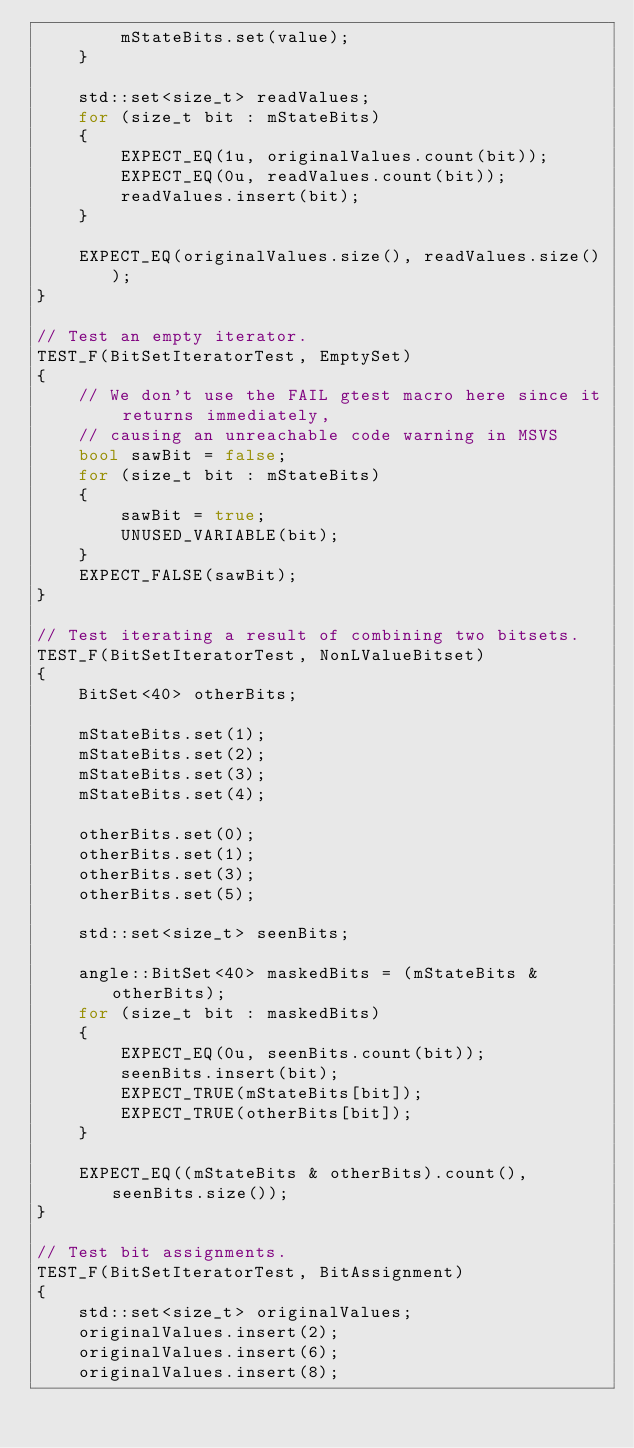Convert code to text. <code><loc_0><loc_0><loc_500><loc_500><_C++_>        mStateBits.set(value);
    }

    std::set<size_t> readValues;
    for (size_t bit : mStateBits)
    {
        EXPECT_EQ(1u, originalValues.count(bit));
        EXPECT_EQ(0u, readValues.count(bit));
        readValues.insert(bit);
    }

    EXPECT_EQ(originalValues.size(), readValues.size());
}

// Test an empty iterator.
TEST_F(BitSetIteratorTest, EmptySet)
{
    // We don't use the FAIL gtest macro here since it returns immediately,
    // causing an unreachable code warning in MSVS
    bool sawBit = false;
    for (size_t bit : mStateBits)
    {
        sawBit = true;
        UNUSED_VARIABLE(bit);
    }
    EXPECT_FALSE(sawBit);
}

// Test iterating a result of combining two bitsets.
TEST_F(BitSetIteratorTest, NonLValueBitset)
{
    BitSet<40> otherBits;

    mStateBits.set(1);
    mStateBits.set(2);
    mStateBits.set(3);
    mStateBits.set(4);

    otherBits.set(0);
    otherBits.set(1);
    otherBits.set(3);
    otherBits.set(5);

    std::set<size_t> seenBits;

    angle::BitSet<40> maskedBits = (mStateBits & otherBits);
    for (size_t bit : maskedBits)
    {
        EXPECT_EQ(0u, seenBits.count(bit));
        seenBits.insert(bit);
        EXPECT_TRUE(mStateBits[bit]);
        EXPECT_TRUE(otherBits[bit]);
    }

    EXPECT_EQ((mStateBits & otherBits).count(), seenBits.size());
}

// Test bit assignments.
TEST_F(BitSetIteratorTest, BitAssignment)
{
    std::set<size_t> originalValues;
    originalValues.insert(2);
    originalValues.insert(6);
    originalValues.insert(8);</code> 